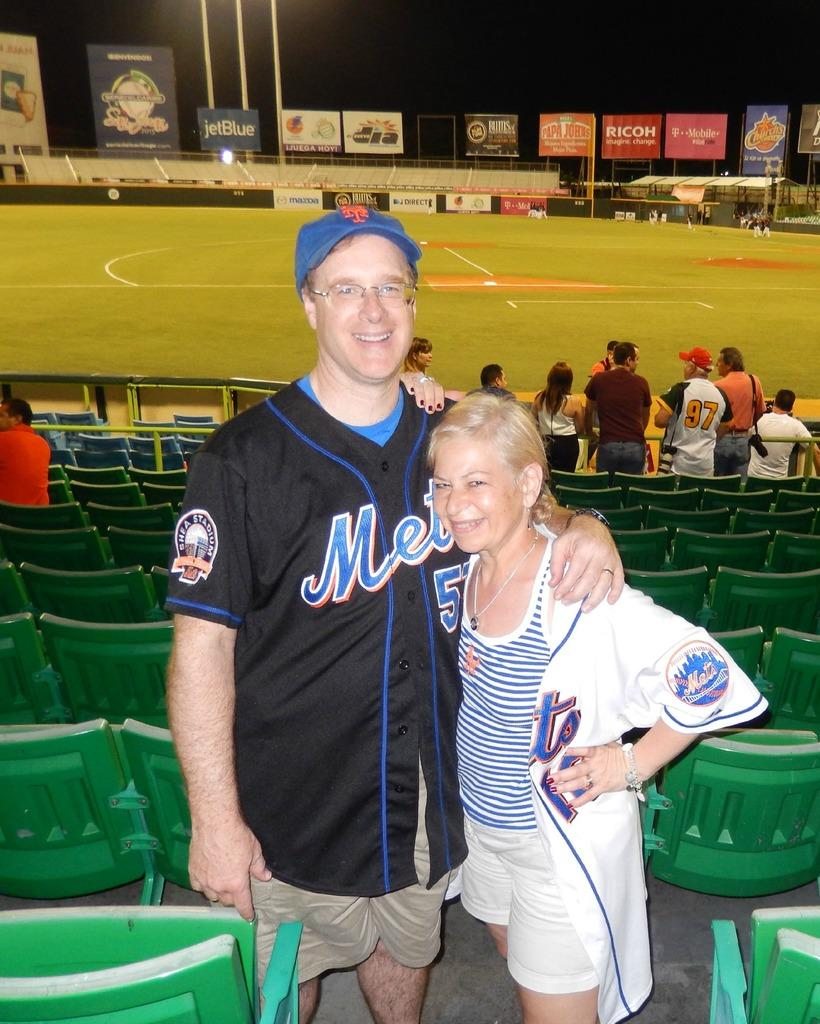<image>
Give a short and clear explanation of the subsequent image. A man an woman wearing Mets jerseys are posing in front of the third base in the stadium. 